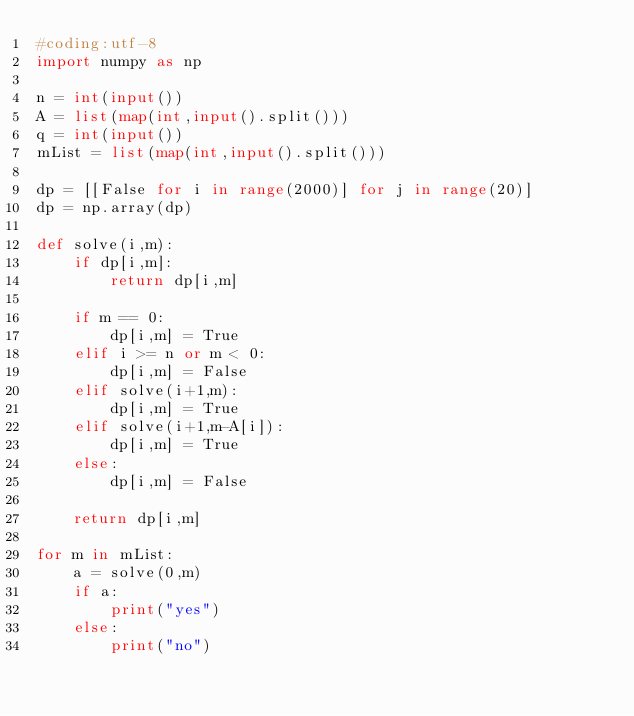Convert code to text. <code><loc_0><loc_0><loc_500><loc_500><_Python_>#coding:utf-8
import numpy as np

n = int(input())
A = list(map(int,input().split()))
q = int(input())
mList = list(map(int,input().split()))

dp = [[False for i in range(2000)] for j in range(20)]
dp = np.array(dp)

def solve(i,m):
    if dp[i,m]:
        return dp[i,m]

    if m == 0:
        dp[i,m] = True
    elif i >= n or m < 0:
        dp[i,m] = False
    elif solve(i+1,m):
        dp[i,m] = True
    elif solve(i+1,m-A[i]):
        dp[i,m] = True
    else:
        dp[i,m] = False

    return dp[i,m]

for m in mList:
    a = solve(0,m)
    if a:
        print("yes")
    else:
        print("no")
           
</code> 